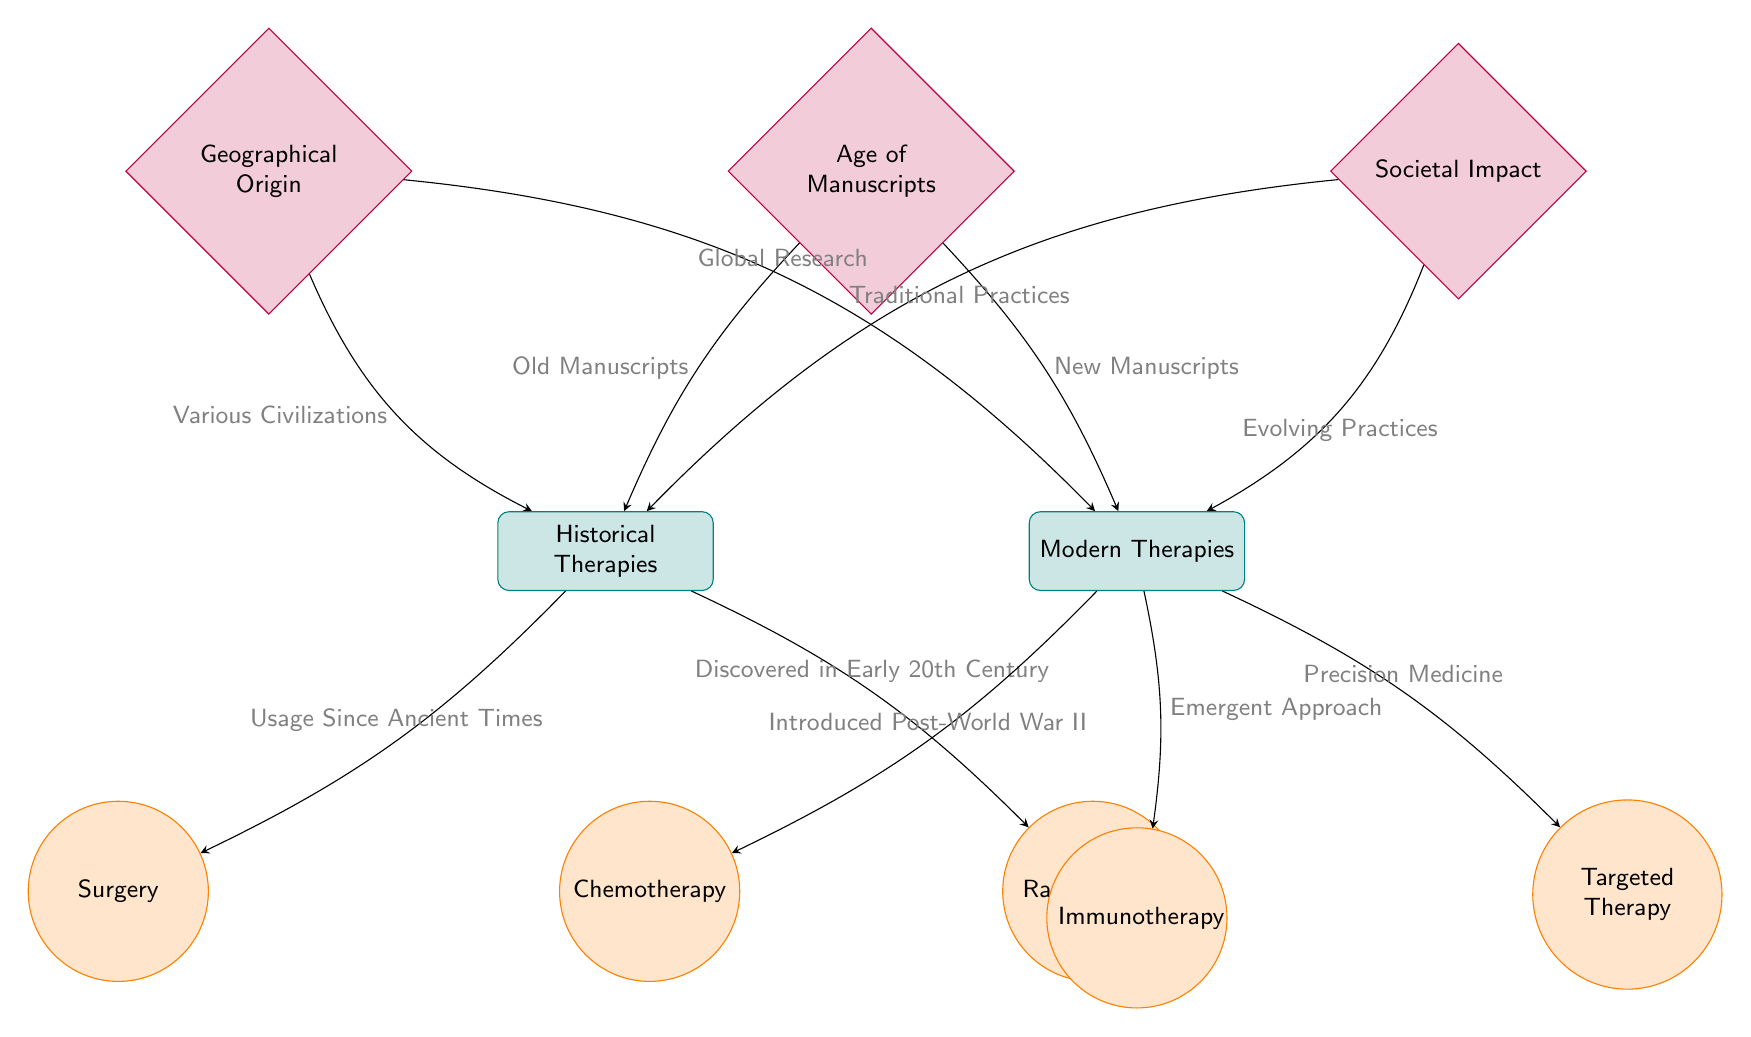What historical therapy is mentioned in the diagram? The diagram includes "Surgery" as a historical therapy under the "Historical Therapies" node. This can be found directly below the "Historical Therapies" category.
Answer: Surgery How many modern therapies are listed in the diagram? The modern therapies listed are "Chemotherapy," "Immunotherapy," and "Targeted Therapy," making a total of three therapies. These are found directly below the "Modern Therapies" category.
Answer: 3 What is the societal impact associated with historical therapies? The diagram states "Traditional Practices" as the societal impact related to historical therapies, which is indicated by the edge leading from "Societal Impact" to the "Historical Therapies" category.
Answer: Traditional Practices What therapy was introduced post-World War II? The therapy "Chemotherapy" is linked with the note "Introduced Post-World War II," which connects directly from the "Modern Therapies" node.
Answer: Chemotherapy What influence do old manuscripts have on historical therapies? According to the diagram, "Old Manuscripts" have a connection that can be observed from the "Age of Manuscripts" factor to the "Historical Therapies" category. This indicates that old manuscripts influence the historical therapies.
Answer: Old Manuscripts Which therapy represents an emergent approach? The diagram identifies "Immunotherapy" as the therapy characterized as an "Emergent Approach," as indicated by the edge connecting "Modern Therapies" to it.
Answer: Immunotherapy What factor affects both historical and modern therapies? The factor "Age of Manuscripts" affects both historical and modern therapies, as indicated by edges connecting this factor to both "Historical Therapies" and "Modern Therapies."
Answer: Age of Manuscripts What geographical origin is associated with historical therapies? The diagram indicates "Various Civilizations" as the geographical origin related to historical therapies, which is derived from the edge connecting "Geographical Origin" to the "Historical Therapies" category.
Answer: Various Civilizations 